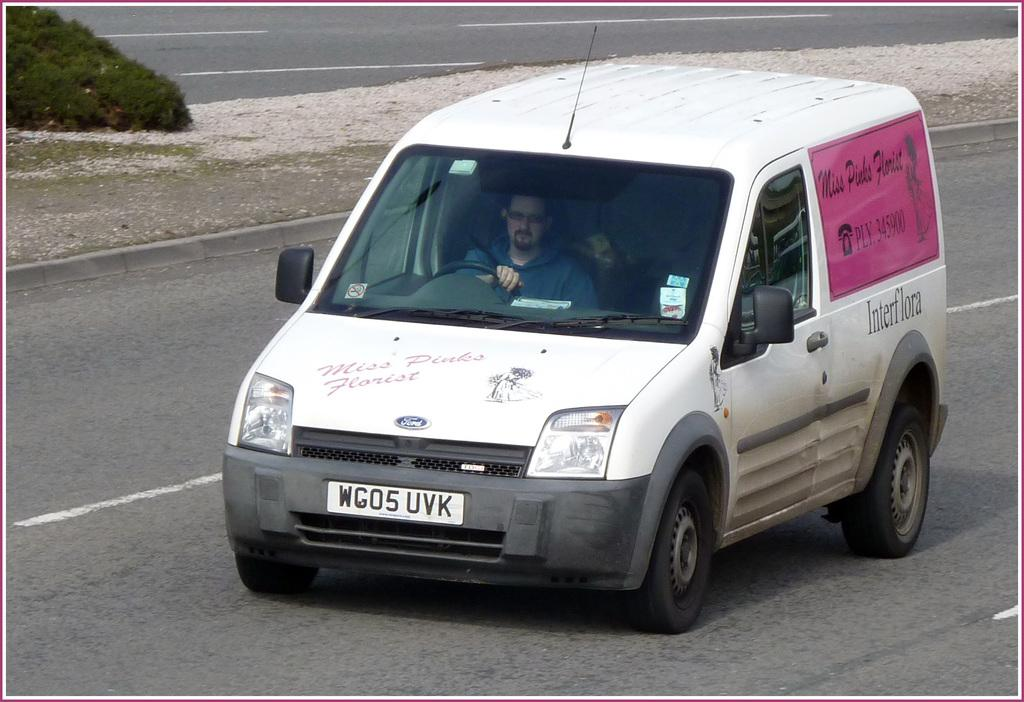What color is the car in the image? The car in the image is white. What is the car doing in the image? The car is moving on the road. Who is driving the car? There is a man driving the car. What can be seen on the car? There is text on the car. What is present on the side of the image? There is a plant on the side of the image. Can you see a gun in the image? No, there is no gun present in the image. 